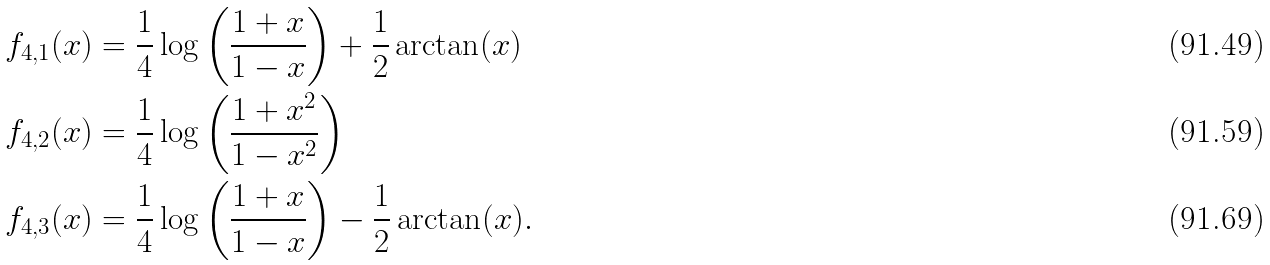Convert formula to latex. <formula><loc_0><loc_0><loc_500><loc_500>f _ { 4 , 1 } ( x ) & = \frac { 1 } { 4 } \log \left ( \frac { 1 + x } { 1 - x } \right ) + \frac { 1 } { 2 } \arctan ( x ) \\ f _ { 4 , 2 } ( x ) & = \frac { 1 } { 4 } \log \left ( \frac { 1 + x ^ { 2 } } { 1 - x ^ { 2 } } \right ) \\ f _ { 4 , 3 } ( x ) & = \frac { 1 } { 4 } \log \left ( \frac { 1 + x } { 1 - x } \right ) - \frac { 1 } { 2 } \arctan ( x ) .</formula> 